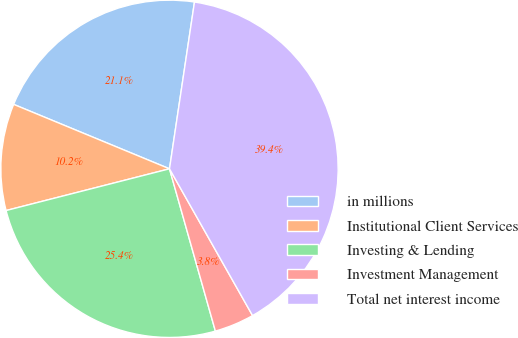<chart> <loc_0><loc_0><loc_500><loc_500><pie_chart><fcel>in millions<fcel>Institutional Client Services<fcel>Investing & Lending<fcel>Investment Management<fcel>Total net interest income<nl><fcel>21.13%<fcel>10.22%<fcel>25.41%<fcel>3.81%<fcel>39.44%<nl></chart> 